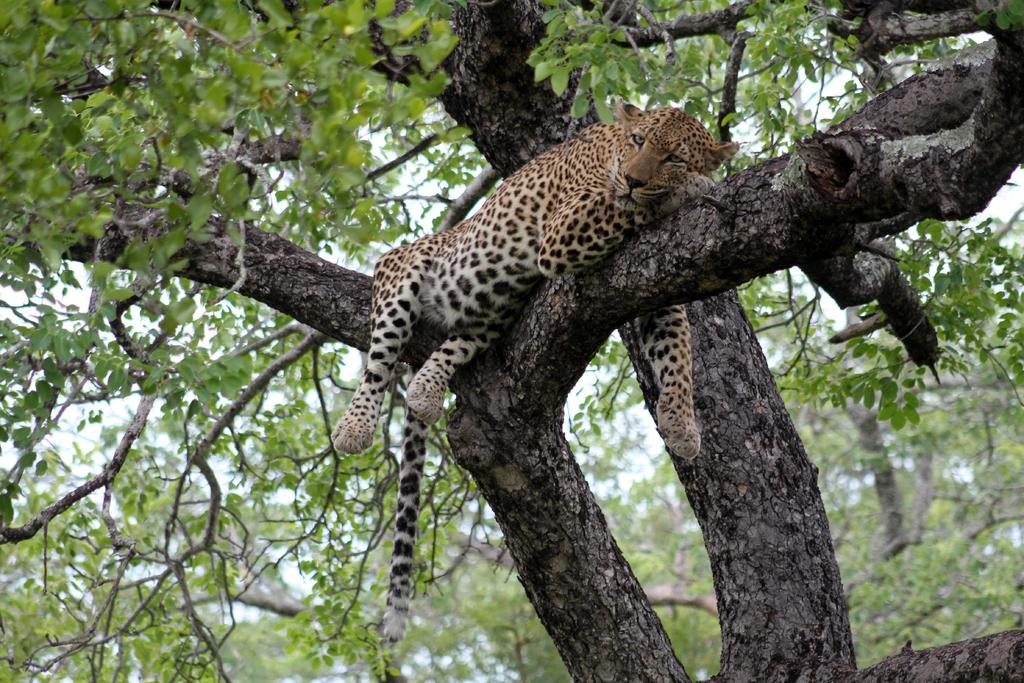What type of environment might the image be taken from? The image might be taken from a forest. What animal can be seen in the image? There is a cheetah lying on a wooden trunk in the image. What can be seen in the background of the image? There are trees and the sky visible in the background of the image. What type of quartz can be seen in the image? There is no quartz present in the image. How does the cheetah maintain a quiet demeanor in the image? The image does not depict the cheetah's demeanor or behavior, so it cannot be determined. 